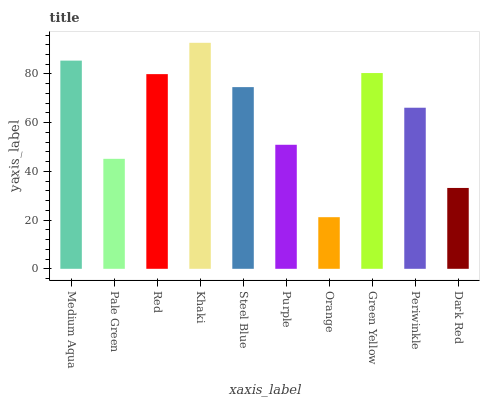Is Orange the minimum?
Answer yes or no. Yes. Is Khaki the maximum?
Answer yes or no. Yes. Is Pale Green the minimum?
Answer yes or no. No. Is Pale Green the maximum?
Answer yes or no. No. Is Medium Aqua greater than Pale Green?
Answer yes or no. Yes. Is Pale Green less than Medium Aqua?
Answer yes or no. Yes. Is Pale Green greater than Medium Aqua?
Answer yes or no. No. Is Medium Aqua less than Pale Green?
Answer yes or no. No. Is Steel Blue the high median?
Answer yes or no. Yes. Is Periwinkle the low median?
Answer yes or no. Yes. Is Dark Red the high median?
Answer yes or no. No. Is Steel Blue the low median?
Answer yes or no. No. 